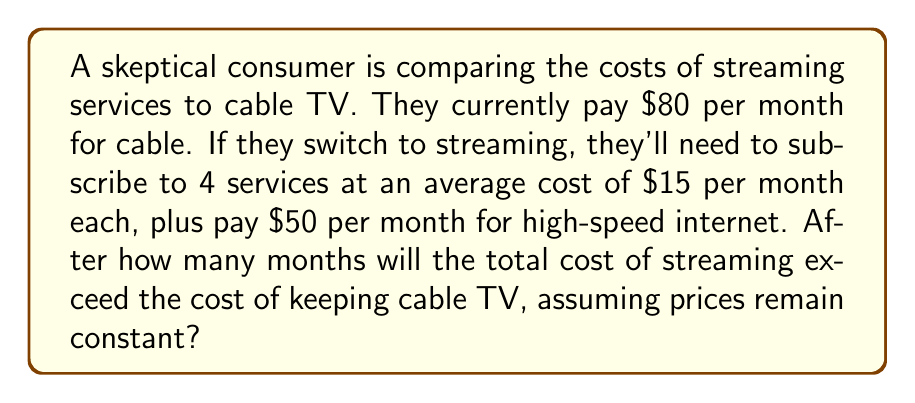Can you solve this math problem? Let's approach this step-by-step:

1. Calculate the monthly cost of streaming:
   - 4 services at $15 each: $4 \times $15 = $60
   - Internet cost: $50
   - Total streaming cost per month: $60 + $50 = $110

2. Calculate the difference in monthly costs:
   - Streaming cost: $110
   - Cable cost: $80
   - Monthly difference: $110 - $80 = $30

3. Set up an equation to find when streaming costs exceed cable:
   Let $x$ be the number of months
   $$80x = 110x - 30x$$

4. Solve the equation:
   $$80x = 80x$$
   $$0 = 0$$

This equation is always true, which means the streaming option is always more expensive from the first month.

5. To find how many months it takes for streaming to exceed cable:
   The difference is $30 per month, so streaming exceeds cable immediately in the first month.
Answer: 1 month 